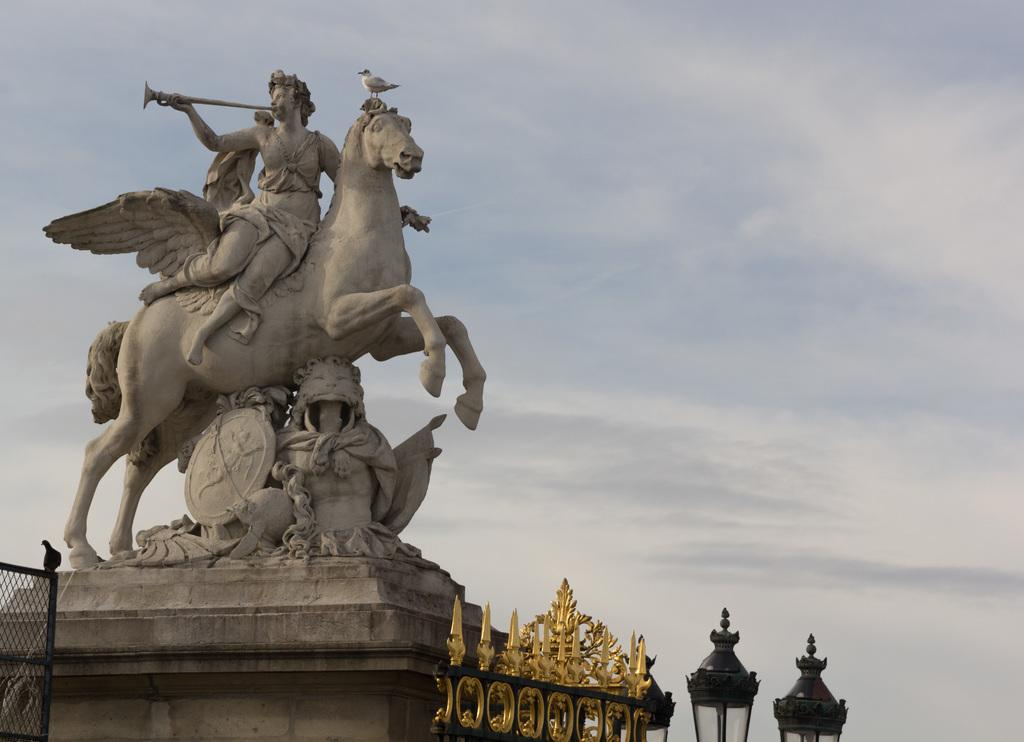What is the main subject in the image? There is a statue in the image. What else can be seen in the image besides the statue? There are lights in the image, as well as a bird on the fencing and an object beside the lights. What is the condition of the sky in the image? The sky is visible in the image. What type of tin can be seen in the image? There is no tin present in the image. Is there any quicksand visible in the image? There is no quicksand present in the image. 